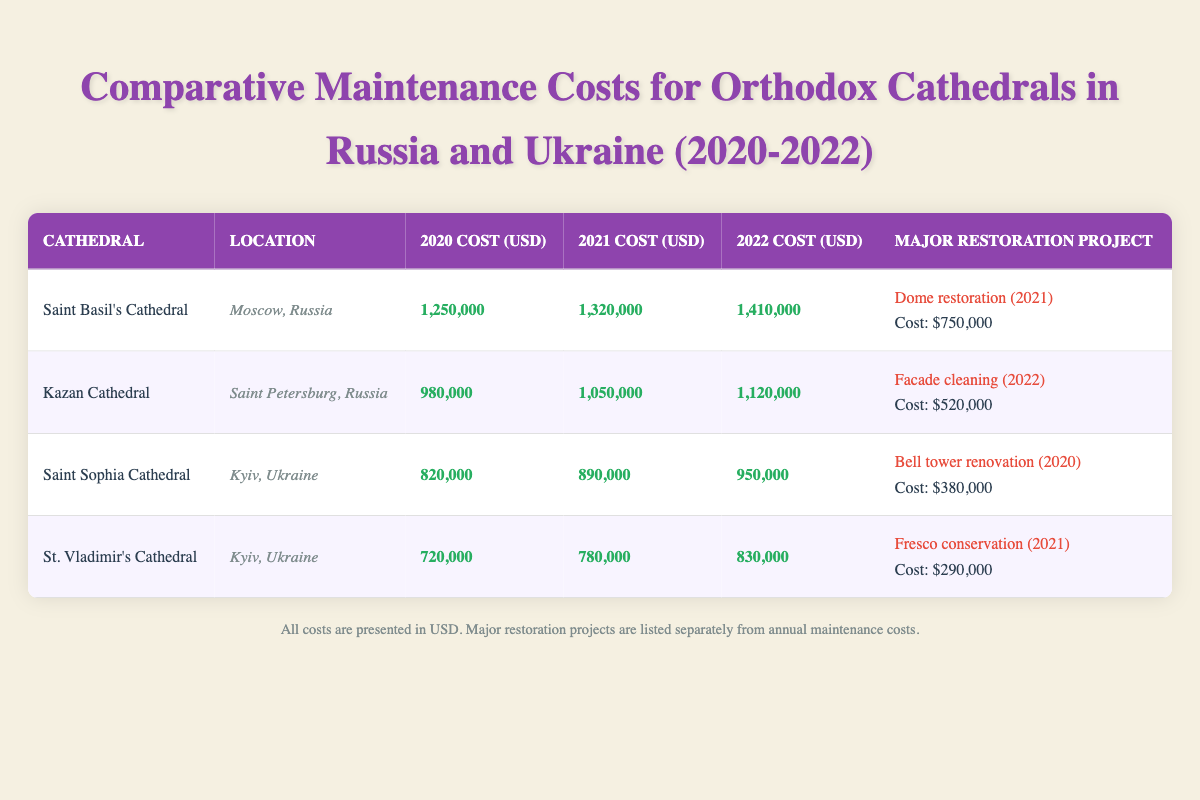What was the annual maintenance cost of Saint Basil's Cathedral in 2021? The table lists the annual maintenance costs for Saint Basil's Cathedral for each year. In 2021, the cost is explicitly mentioned as 1,320,000 USD.
Answer: 1,320,000 USD Which cathedral had the highest maintenance cost in 2022? Comparing the annual maintenance costs for each cathedral in 2022, Saint Basil's Cathedral has the highest cost at 1,410,000 USD, while the others range lower.
Answer: Saint Basil's Cathedral What is the total cost of major restoration projects for Kazan Cathedral? The only major restoration project listed for Kazan Cathedral is the facade cleaning in 2022, which cost 520,000 USD. Therefore, the total cost of major restoration projects is exactly this amount.
Answer: 520,000 USD Did St. Vladimir's Cathedral have any major restoration projects in 2020? The table shows that St. Vladimir's Cathedral had a major restoration project listed only for 2021, which was fresco conservation. Thus, there were no projects listed in 2020.
Answer: No What was the average annual maintenance cost for Saint Sophia Cathedral from 2020 to 2022? To find the average, add the annual maintenance costs for Saint Sophia Cathedral for the three years: (820,000 + 890,000 + 950,000) = 2,660,000 USD. Then divide by 3 to get the average: 2,660,000 / 3 = 886,666.67 USD.
Answer: 886,666.67 USD What is the percentage of funding for Orthodox cathedrals that comes from private donations? According to the funding sources, private donations represent 30% of the funding for Orthodox cathedrals. This figure is directly stated in the table.
Answer: 30% Which location had a higher average maintenance cost over the three years, Moscow or Kyiv? Sum the annual maintenance costs for cathedrals in Moscow: Saint Basil's Cathedral (1,250,000 + 1,320,000 + 1,410,000 = 3,980,000 USD) and Kazan Cathedral (980,000 + 1,050,000 + 1,120,000 = 3,150,000 USD), giving an average of (3,980,000 + 3,150,000) / 2 = 3,565,000 USD for Moscow. For Kyiv, the sum for Saint Sophia Cathedral and St. Vladimir's Cathedral is (820,000 + 890,000 + 950,000 + 720,000 + 780,000 + 830,000) = 4,990,000 USD, resulting in an average of 4,990,000 / 2 = 2,495,000 USD for one cathedral each. Comparing averages shows that Moscow had a higher average maintenance cost.
Answer: Moscow Was the cost for structural repairs greater than the total cost of plumbing and drainage for any cathedral? Structural repairs account for 30% of the total maintenance costs for each cathedral. For example, for Saint Basil's Cathedral in 2022, the structural repair cost would be 0.30 * 1,410,000 = 423,000 USD. The total cost of plumbing and drainage accounting for 8% of the same may be calculated as 0.08 * 1,410,000 = 112,800 USD. Thus, structural repairs were greater than plumbing and drainage costs. This same reasoning applies to all cathedrals, confirming the statement is true.
Answer: Yes 